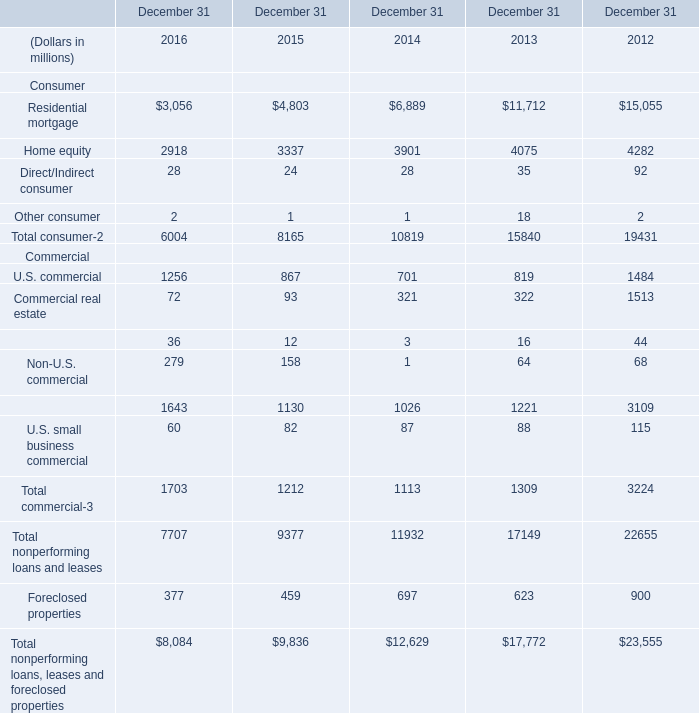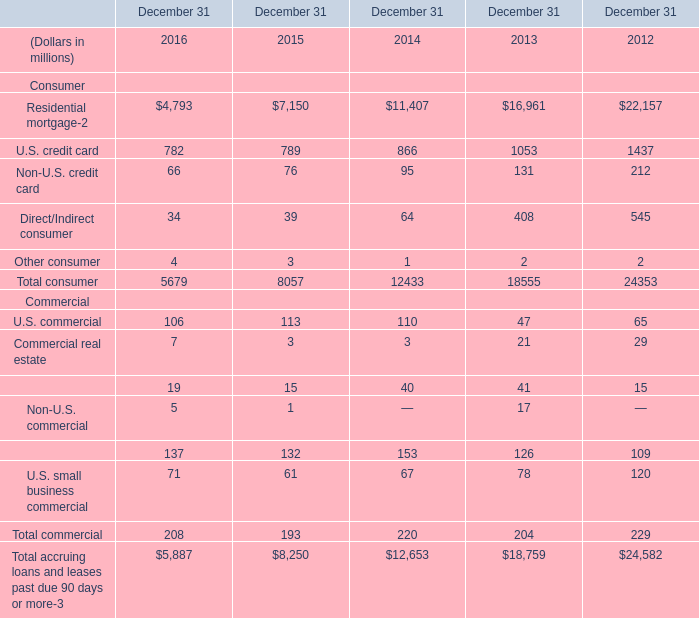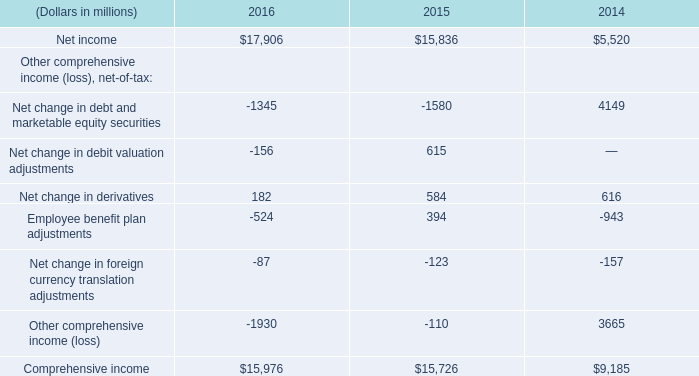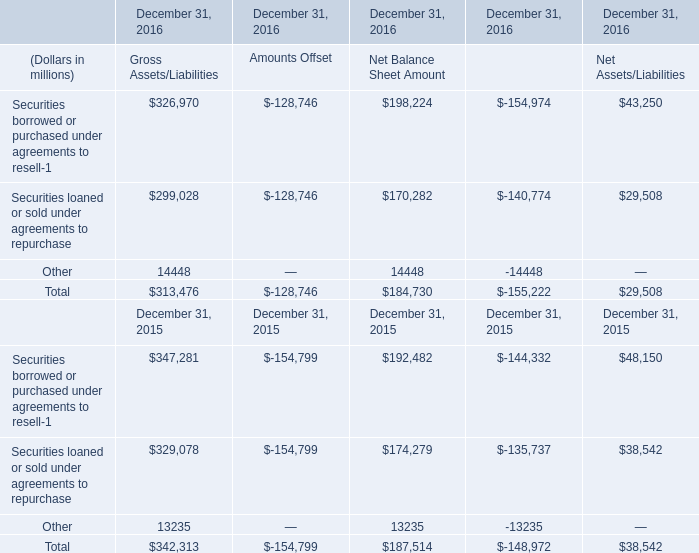What's the average of Total consumer in 2014,2015 and 2016? (in million) 
Computations: (((5679 + 8057) + 12433) / 3)
Answer: 8723.0. 